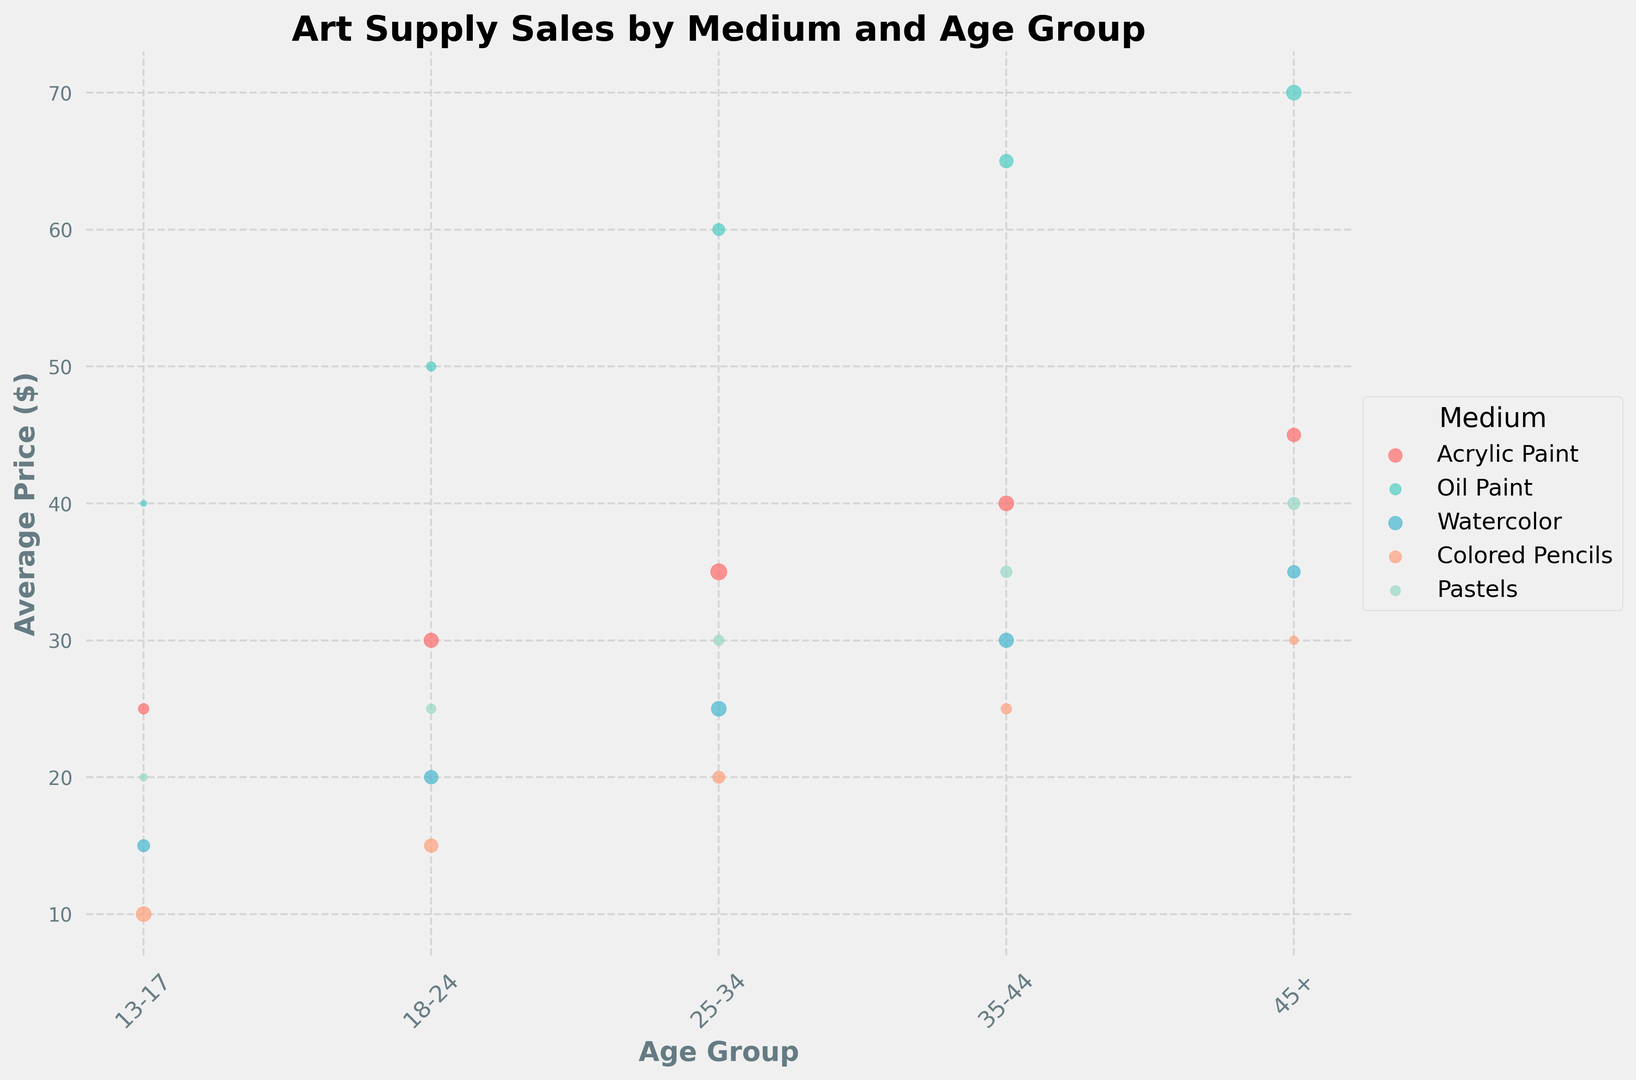What age group bought the most watercolor paint and how much did they buy? Look for the largest bubble in the watercolor row. The largest bubble is in the '25-34' age group. Check the figure for the sales volume of that age group.
Answer: 25-34, 30000 Which medium has the highest average price in the '18-24' age group? Identify the position for the '18-24' age group on the x-axis. Then look for the tallest bubble at that position. The tallest bubble belongs to Oil Paint with an average price of $50.
Answer: Oil Paint, $50 How does the average price of acrylic paint change as the age group increases from '13-17' to '45+'? Trace the bubbles for acrylic paint across age groups from '13-17' to '45+'. Note the prices: $25 (13-17), $30 (18-24), $35 (25-34), $40 (35-44), $45 (45+). Observe the trend that the average price increases steadily.
Answer: Increases steadily What's the sales volume difference between the '13-17' and '45+' age groups for colored pencils? Find the bubbles for colored pencils in the '13-17' and '45+' age groups. Note their sizes, representing 30000 and 10000 respectively. The sales volume difference is 30000 - 10000 = 20000.
Answer: 20000 Which medium had consistently increasing average prices as age groups increased from '13-17' to '45+'? Identify each medium's price trend across age groups. Only Acrylic Paint shows a consistent increase: $25 (13-17), $30 (18-24), $35 (25-34), $40 (35-44), $45 (45+).
Answer: Acrylic Paint Which age group has the highest combined sales volume for all mediums? Sum the sales volumes for each age group across all mediums. Calculations: 
- 13-17: (15000+5000+20000+30000+8000) = 78000
- 18-24: (28000+12000+25000+25000+12000) = 102000
- 25-34: (35000+20000+30000+20000+15000) = 120000
- 35-44: (30000+25000+28000+15000+18000) = 116000
- 45+: (25000+30000+22000+10000+20000) = 107000
The highest combined sales volume is for '25-34'.
Answer: 25-34 Which two age groups have the closest average prices for Pastels? Check the average prices for Pastels in different age groups: $20 (13-17), $25 (18-24), $30 (25-34), $35 (35-44), $40 (45+). The closest ones are '25-34' and '18-24' with a difference of $30 - $25 = $5.
Answer: 18-24 and 25-34 What is the total sales volume of Acrylic Paint for all age groups? Add the sales volumes of Acrylic Paint across all age groups: 15000+28000+35000+30000+25000 = 133000.
Answer: 133000 What age group had the lowest sales volume for Oil Paint and what was the amount? Find the smallest bubble in the Oil Paint row. The smallest bubble is in the '13-17' age group. Check the figure for the sales volume of that age group.
Answer: 13-17, 5000 What's the average price difference between the most and least expensive medium for the '35-44' age group? Find the medium with the highest average price: Oil Paint ($65). Find the medium with the lowest average price: Colored Pencils ($25). The difference is $65 - $25 = $40.
Answer: $40 